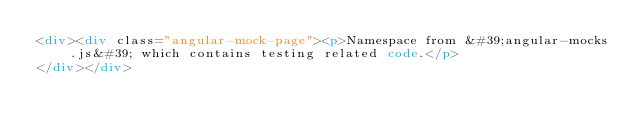Convert code to text. <code><loc_0><loc_0><loc_500><loc_500><_HTML_><div><div class="angular-mock-page"><p>Namespace from &#39;angular-mocks.js&#39; which contains testing related code.</p>
</div></div>
</code> 